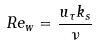<formula> <loc_0><loc_0><loc_500><loc_500>R e _ { w } = \frac { u _ { \tau } k _ { s } } { \nu }</formula> 